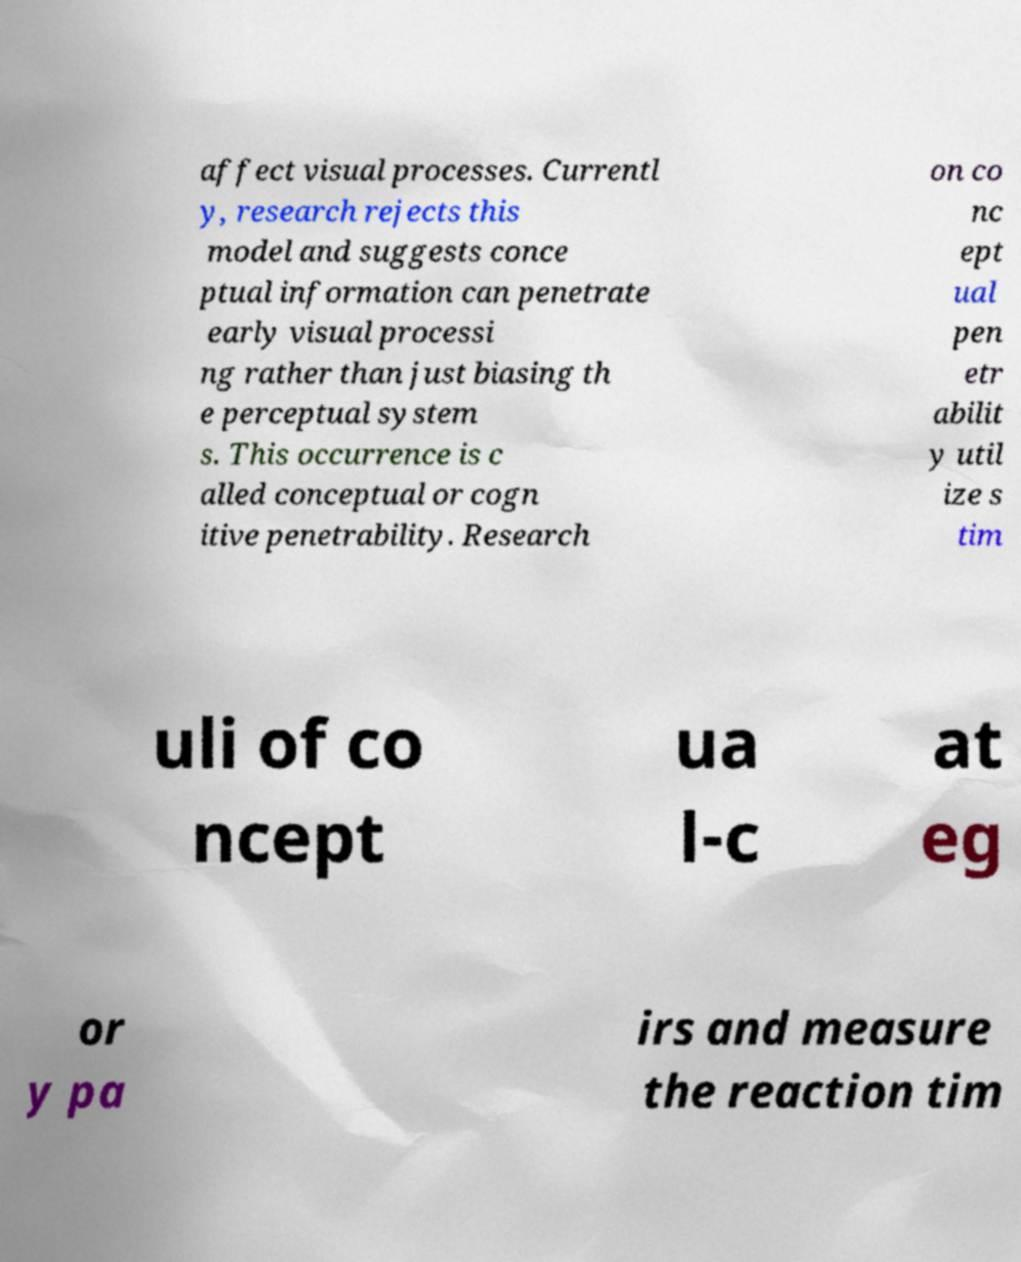Can you accurately transcribe the text from the provided image for me? affect visual processes. Currentl y, research rejects this model and suggests conce ptual information can penetrate early visual processi ng rather than just biasing th e perceptual system s. This occurrence is c alled conceptual or cogn itive penetrability. Research on co nc ept ual pen etr abilit y util ize s tim uli of co ncept ua l-c at eg or y pa irs and measure the reaction tim 